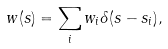Convert formula to latex. <formula><loc_0><loc_0><loc_500><loc_500>w ( s ) = \sum _ { i } w _ { i } \delta ( s - s _ { i } ) ,</formula> 